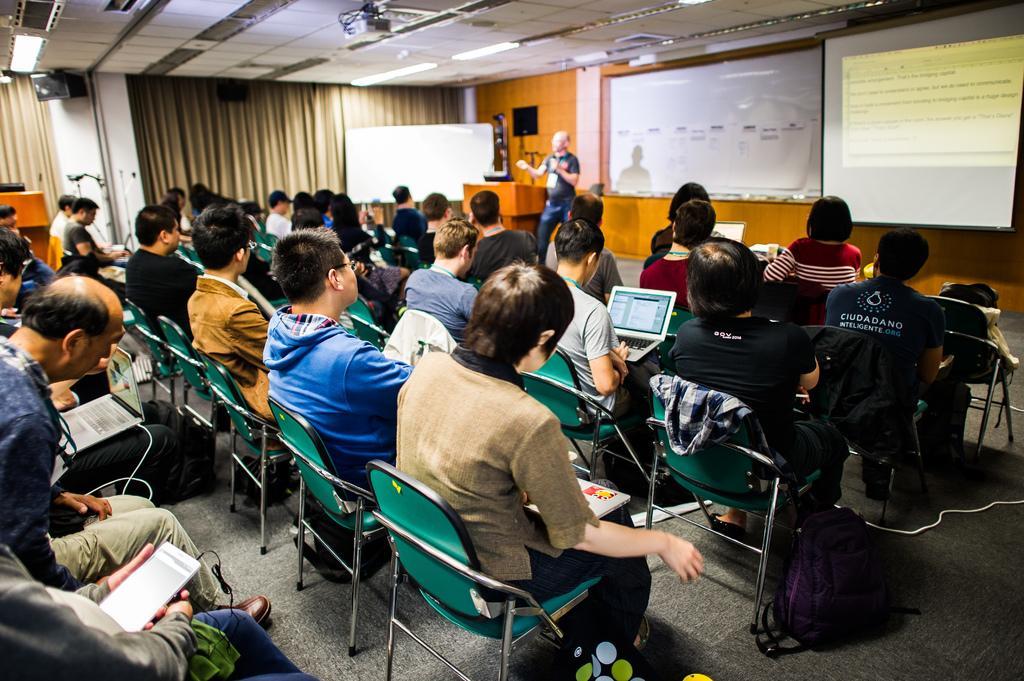Can you describe this image briefly? In this image, we can see a group of people. They are sitting on the chairs. Here we can see few bags on the floor. Background we can see wall, curtains, board, speaker. Here a person is standing near the podium. Right side of the image, we can see the screen. Top of the image, we can see the ceiling, lights and projector. 